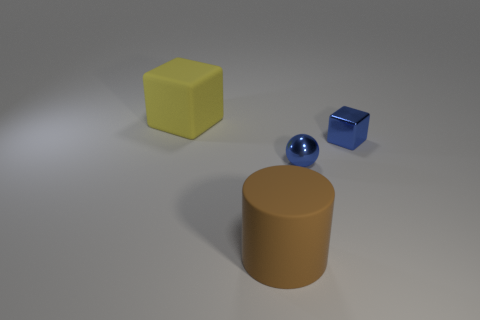Add 1 yellow matte cylinders. How many objects exist? 5 Subtract all cylinders. How many objects are left? 3 Add 3 balls. How many balls are left? 4 Add 4 tiny spheres. How many tiny spheres exist? 5 Subtract 0 red spheres. How many objects are left? 4 Subtract all large rubber things. Subtract all matte cylinders. How many objects are left? 1 